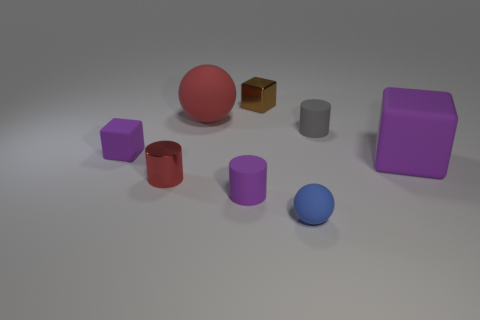Do the ball that is behind the small metal cylinder and the tiny metal thing in front of the tiny brown metallic thing have the same color?
Make the answer very short. Yes. There is a gray rubber thing; what number of small purple cylinders are on the right side of it?
Provide a succinct answer. 0. How big is the purple rubber cylinder?
Give a very brief answer. Small. The big block that is the same material as the small purple cylinder is what color?
Make the answer very short. Purple. How many metallic objects are the same size as the red cylinder?
Ensure brevity in your answer.  1. Does the small red cylinder that is in front of the tiny gray rubber thing have the same material as the tiny gray cylinder?
Your answer should be compact. No. Are there fewer purple rubber things in front of the tiny rubber cube than red matte things?
Keep it short and to the point. No. The tiny metallic object left of the tiny purple cylinder has what shape?
Your answer should be compact. Cylinder. The brown thing that is the same size as the blue ball is what shape?
Offer a very short reply. Cube. Is there another matte thing of the same shape as the big purple object?
Your answer should be very brief. Yes. 